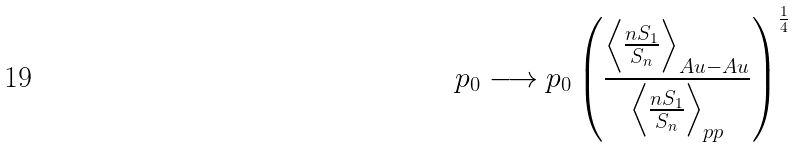<formula> <loc_0><loc_0><loc_500><loc_500>p _ { 0 } \longrightarrow p _ { 0 } \left ( \frac { \left < \frac { n S _ { 1 } } { S _ { n } } \right > _ { A u - A u } } { \left < \frac { n S _ { 1 } } { S _ { n } } \right > _ { p p } } \right ) ^ { \frac { 1 } { 4 } }</formula> 